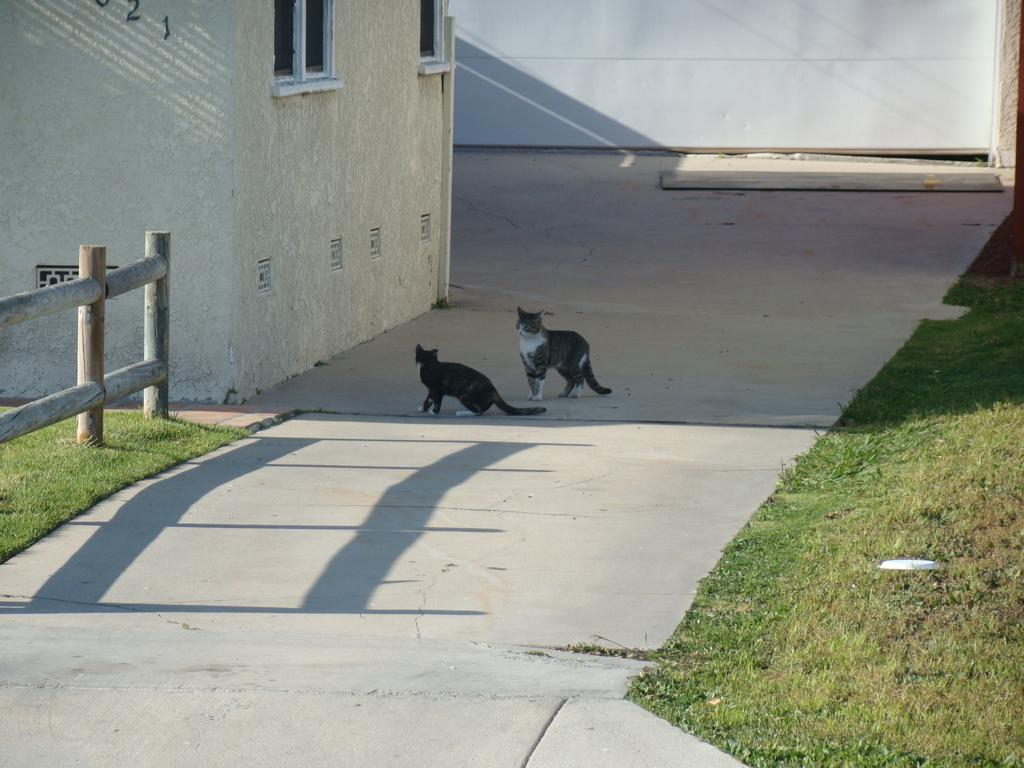What animals can be seen on the road in the image? There are two cats visible on the road in the image. What structure is located in the top left of the image? There is a building in the top left of the image. What type of barrier is present in the top left of the image? There is a fence in the top left of the image. What is the main pathway visible in the image? There is a road in the middle of the image. What is visible at the top of the image? There is a board visible at the top of the image. Can you see any steam coming from the cats in the image? There is no steam visible in the image, and the cats are not producing steam. What type of instrument is being played by the cats in the image? There are no instruments present in the image, and the cats are not playing any instruments. 